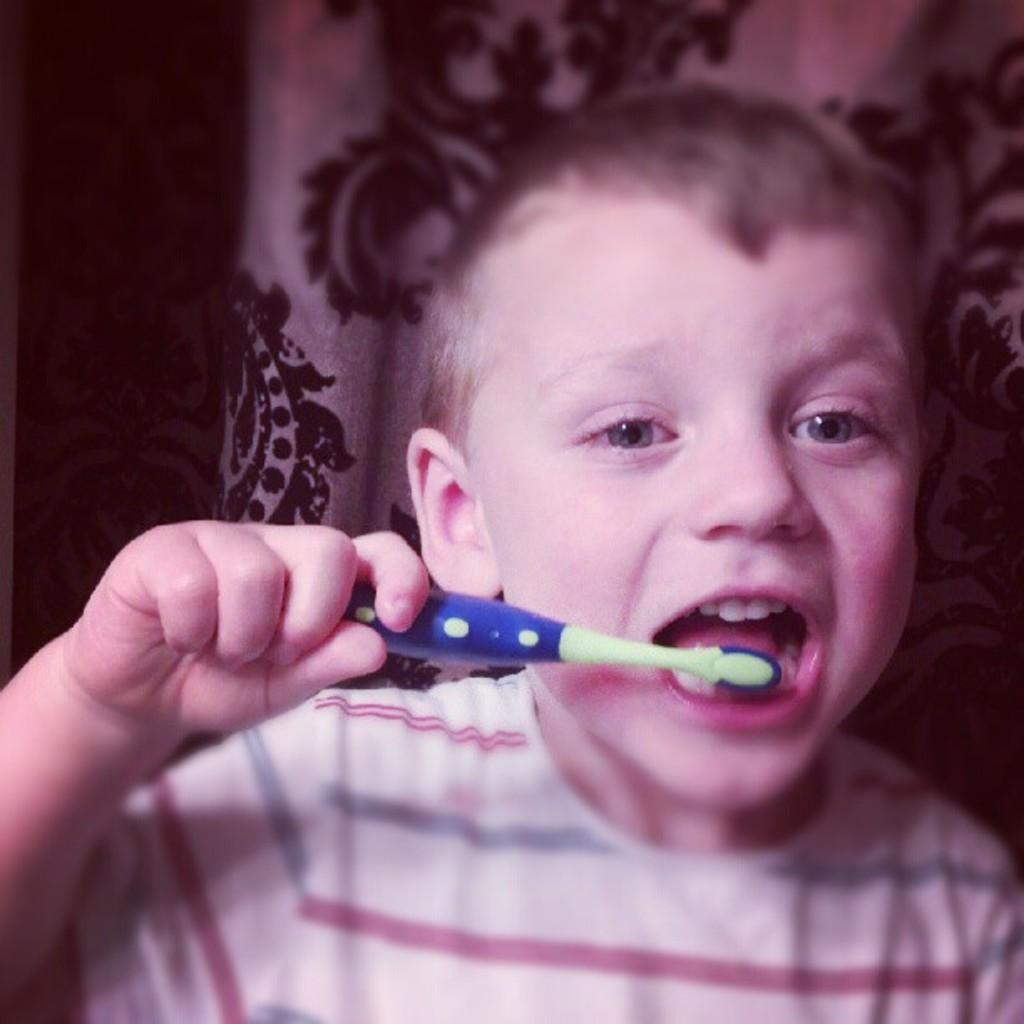What is present in the image? There is a person in the image. What is the person doing in the image? The person is holding an object. What can be seen in the background of the image? There is cloth visible in the background of the image. How many kittens are playing with the produce in the image? There are no kittens or produce present in the image. What type of star can be seen in the image? There is no star visible in the image. 